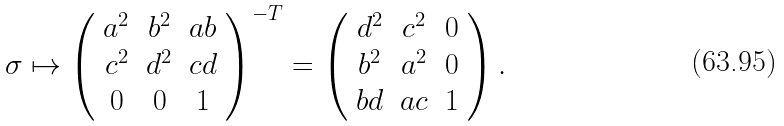<formula> <loc_0><loc_0><loc_500><loc_500>\sigma \mapsto \left ( \begin{array} { c c c } a ^ { 2 } & b ^ { 2 } & a b \\ c ^ { 2 } & d ^ { 2 } & c d \\ 0 & 0 & 1 \end{array} \right ) ^ { - T } = \left ( \begin{array} { c c c } d ^ { 2 } & c ^ { 2 } & 0 \\ b ^ { 2 } & a ^ { 2 } & 0 \\ b d & a c & 1 \end{array} \right ) .</formula> 